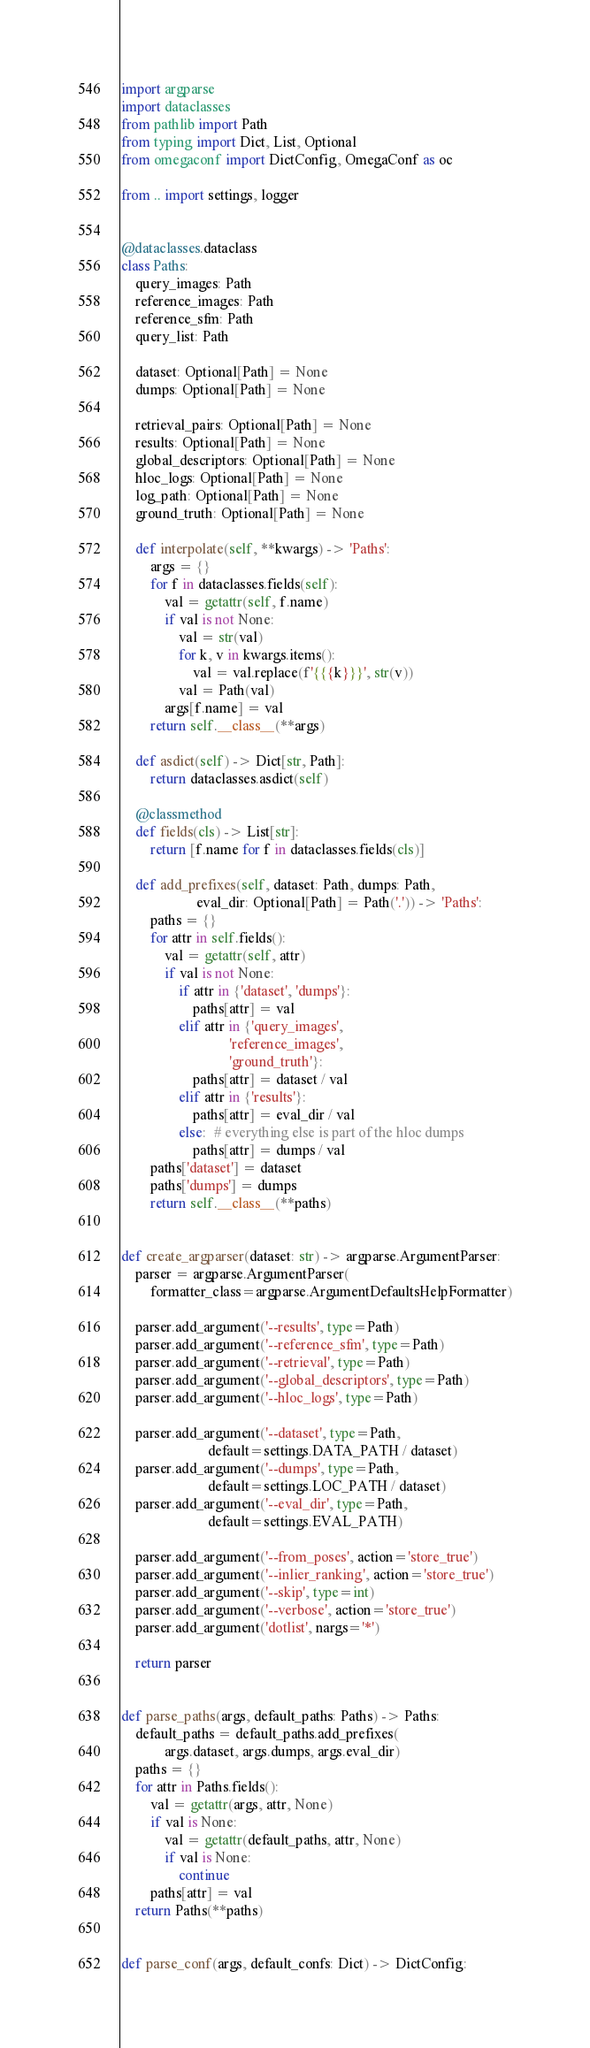<code> <loc_0><loc_0><loc_500><loc_500><_Python_>import argparse
import dataclasses
from pathlib import Path
from typing import Dict, List, Optional
from omegaconf import DictConfig, OmegaConf as oc

from .. import settings, logger


@dataclasses.dataclass
class Paths:
    query_images: Path
    reference_images: Path
    reference_sfm: Path
    query_list: Path

    dataset: Optional[Path] = None
    dumps: Optional[Path] = None

    retrieval_pairs: Optional[Path] = None
    results: Optional[Path] = None
    global_descriptors: Optional[Path] = None
    hloc_logs: Optional[Path] = None
    log_path: Optional[Path] = None
    ground_truth: Optional[Path] = None

    def interpolate(self, **kwargs) -> 'Paths':
        args = {}
        for f in dataclasses.fields(self):
            val = getattr(self, f.name)
            if val is not None:
                val = str(val)
                for k, v in kwargs.items():
                    val = val.replace(f'{{{k}}}', str(v))
                val = Path(val)
            args[f.name] = val
        return self.__class__(**args)

    def asdict(self) -> Dict[str, Path]:
        return dataclasses.asdict(self)

    @classmethod
    def fields(cls) -> List[str]:
        return [f.name for f in dataclasses.fields(cls)]

    def add_prefixes(self, dataset: Path, dumps: Path,
                     eval_dir: Optional[Path] = Path('.')) -> 'Paths':
        paths = {}
        for attr in self.fields():
            val = getattr(self, attr)
            if val is not None:
                if attr in {'dataset', 'dumps'}:
                    paths[attr] = val
                elif attr in {'query_images',
                              'reference_images',
                              'ground_truth'}:
                    paths[attr] = dataset / val
                elif attr in {'results'}:
                    paths[attr] = eval_dir / val
                else:  # everything else is part of the hloc dumps
                    paths[attr] = dumps / val
        paths['dataset'] = dataset
        paths['dumps'] = dumps
        return self.__class__(**paths)


def create_argparser(dataset: str) -> argparse.ArgumentParser:
    parser = argparse.ArgumentParser(
        formatter_class=argparse.ArgumentDefaultsHelpFormatter)

    parser.add_argument('--results', type=Path)
    parser.add_argument('--reference_sfm', type=Path)
    parser.add_argument('--retrieval', type=Path)
    parser.add_argument('--global_descriptors', type=Path)
    parser.add_argument('--hloc_logs', type=Path)

    parser.add_argument('--dataset', type=Path,
                        default=settings.DATA_PATH / dataset)
    parser.add_argument('--dumps', type=Path,
                        default=settings.LOC_PATH / dataset)
    parser.add_argument('--eval_dir', type=Path,
                        default=settings.EVAL_PATH)

    parser.add_argument('--from_poses', action='store_true')
    parser.add_argument('--inlier_ranking', action='store_true')
    parser.add_argument('--skip', type=int)
    parser.add_argument('--verbose', action='store_true')
    parser.add_argument('dotlist', nargs='*')

    return parser


def parse_paths(args, default_paths: Paths) -> Paths:
    default_paths = default_paths.add_prefixes(
            args.dataset, args.dumps, args.eval_dir)
    paths = {}
    for attr in Paths.fields():
        val = getattr(args, attr, None)
        if val is None:
            val = getattr(default_paths, attr, None)
            if val is None:
                continue
        paths[attr] = val
    return Paths(**paths)


def parse_conf(args, default_confs: Dict) -> DictConfig:</code> 